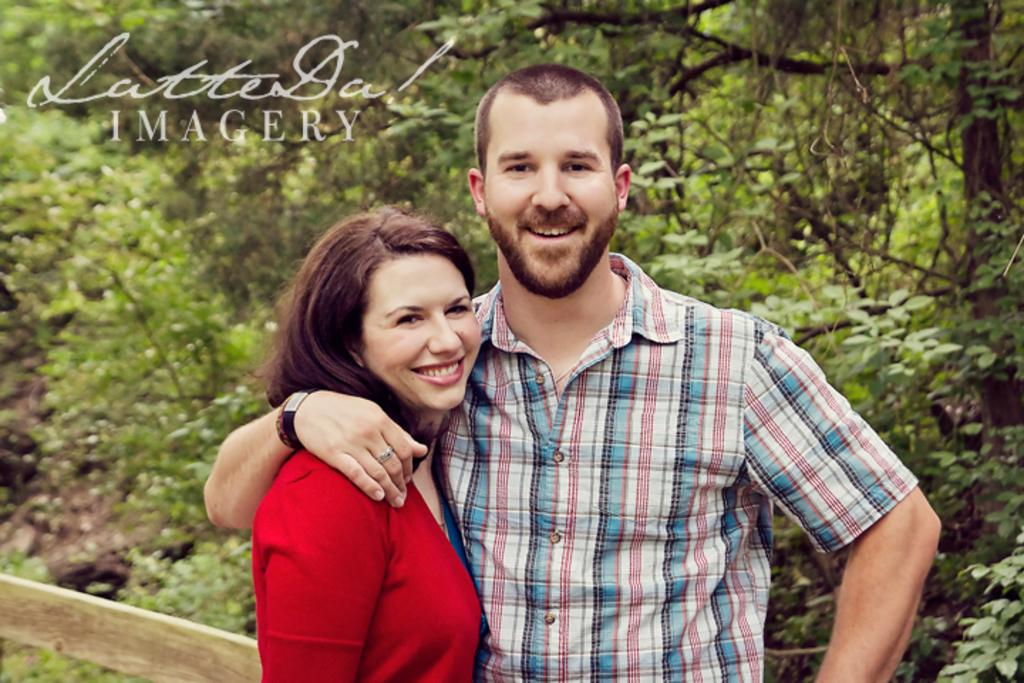How many people are present in the image? There are two people standing in the image. What is the facial expression of the people in the image? The people are smiling. What can be seen in the background of the image? There are trees visible in the background of the image. What is located on the left bottom of the image? There is a boundary wall on the left bottom of the image. What type of discussion is taking place between the people in the image? There is no indication of a discussion taking place in the image; the people are simply standing and smiling. How many cars can be seen in the image? There are no cars present in the image. 